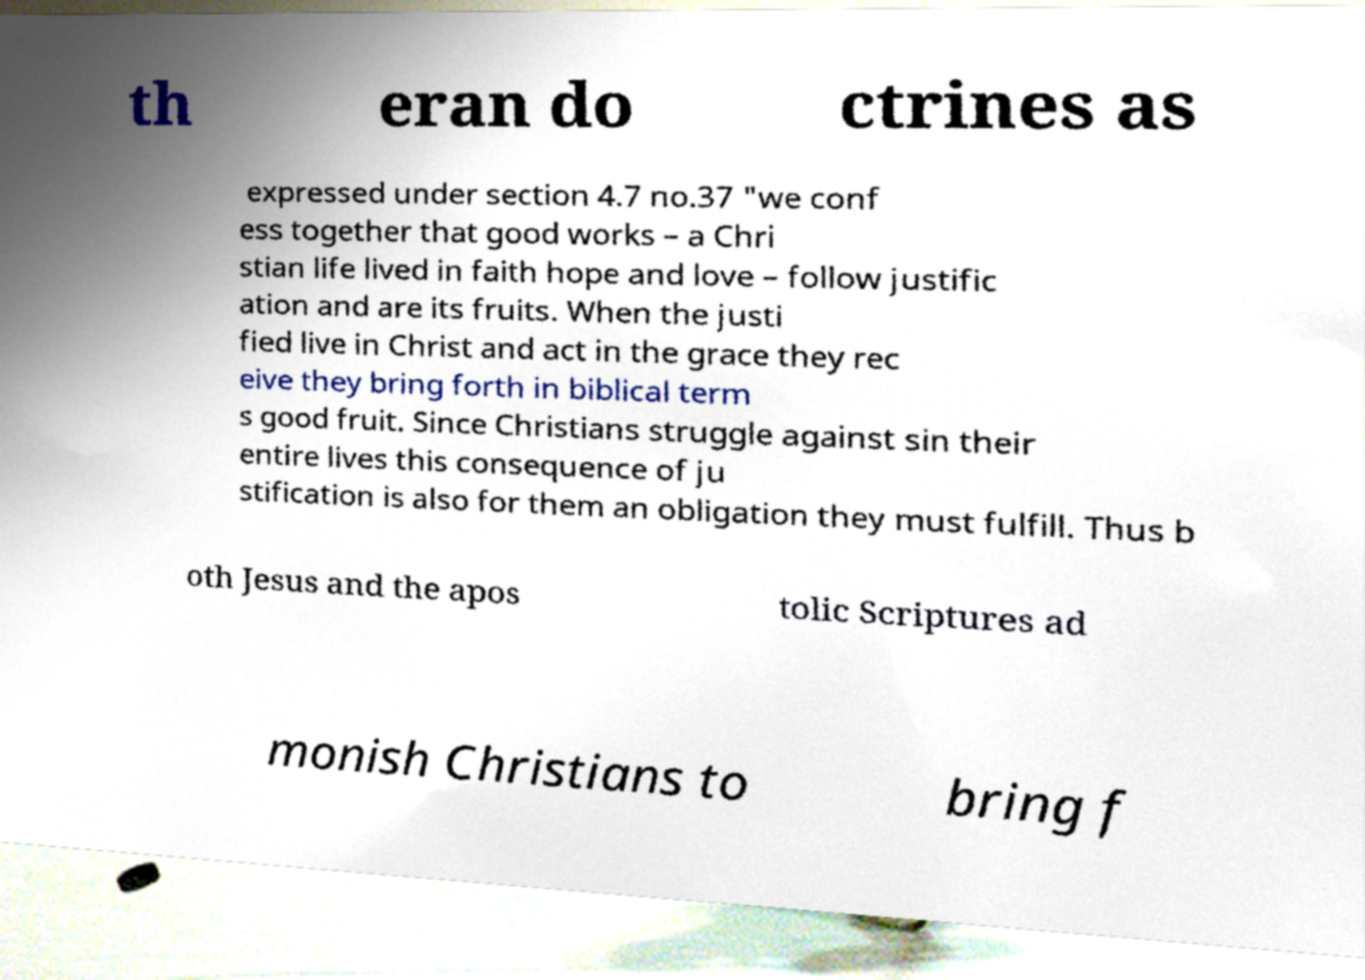I need the written content from this picture converted into text. Can you do that? th eran do ctrines as expressed under section 4.7 no.37 "we conf ess together that good works – a Chri stian life lived in faith hope and love – follow justific ation and are its fruits. When the justi fied live in Christ and act in the grace they rec eive they bring forth in biblical term s good fruit. Since Christians struggle against sin their entire lives this consequence of ju stification is also for them an obligation they must fulfill. Thus b oth Jesus and the apos tolic Scriptures ad monish Christians to bring f 